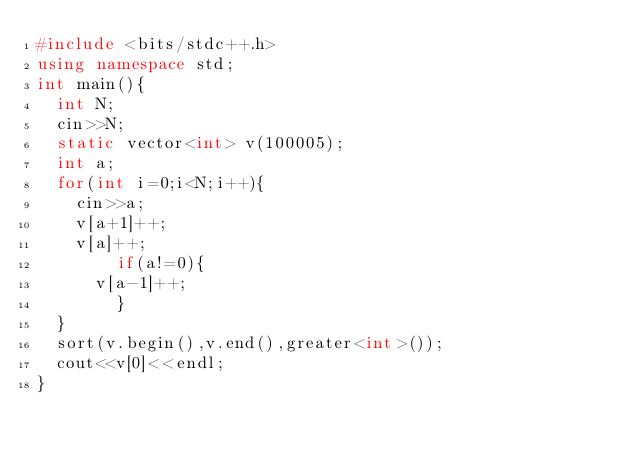<code> <loc_0><loc_0><loc_500><loc_500><_C++_>#include <bits/stdc++.h>
using namespace std;
int main(){
	int N;
	cin>>N;
	static vector<int> v(100005);
	int a;
	for(int i=0;i<N;i++){
		cin>>a;
		v[a+1]++;
		v[a]++;
      	if(a!=0){
			v[a-1]++;
        }
	}
	sort(v.begin(),v.end(),greater<int>());
	cout<<v[0]<<endl;
}</code> 